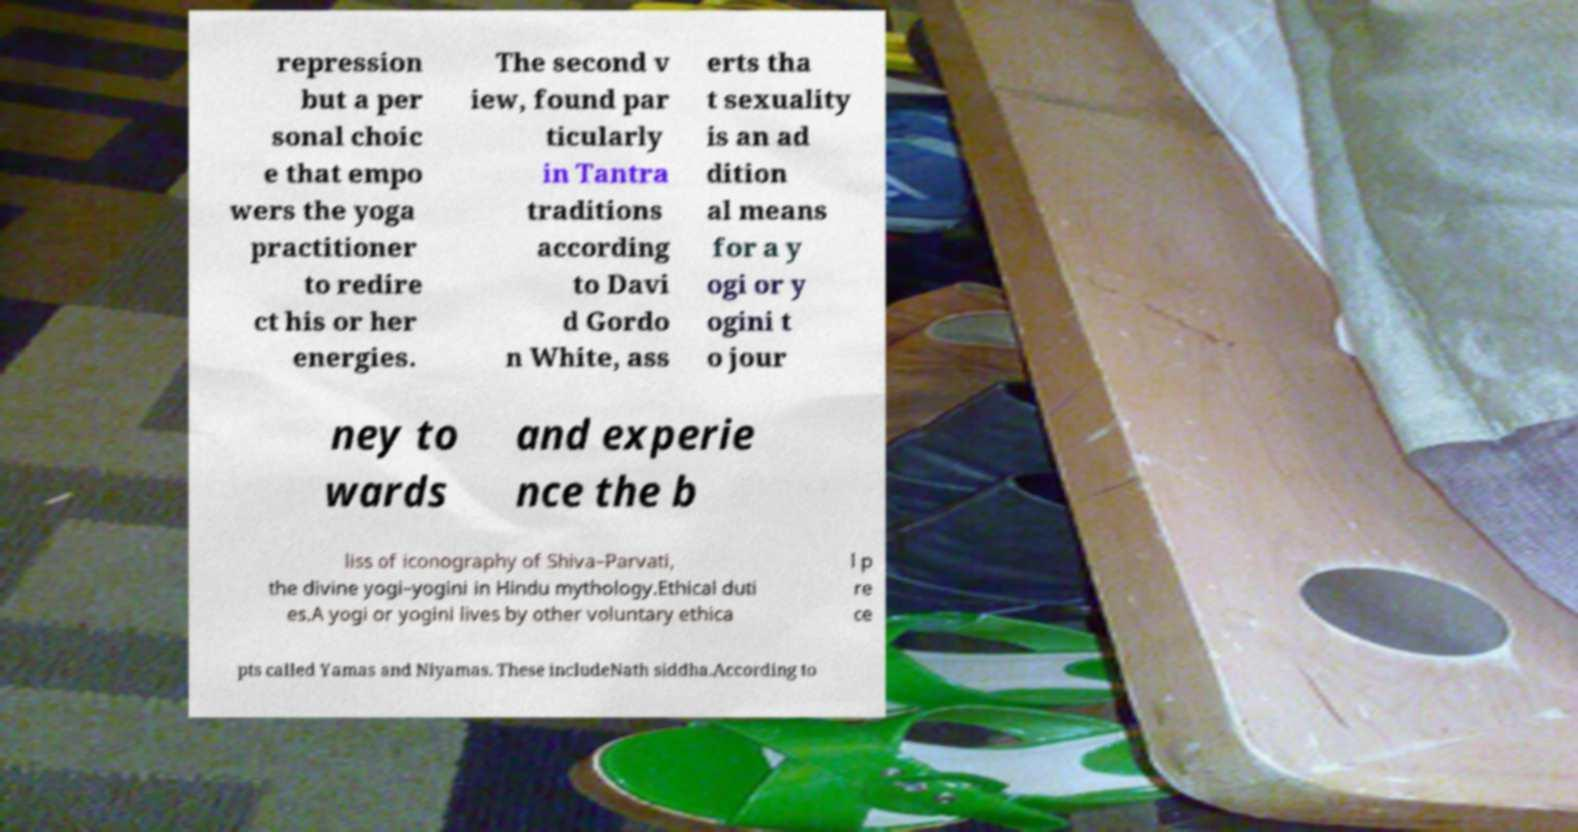For documentation purposes, I need the text within this image transcribed. Could you provide that? repression but a per sonal choic e that empo wers the yoga practitioner to redire ct his or her energies. The second v iew, found par ticularly in Tantra traditions according to Davi d Gordo n White, ass erts tha t sexuality is an ad dition al means for a y ogi or y ogini t o jour ney to wards and experie nce the b liss of iconography of Shiva–Parvati, the divine yogi–yogini in Hindu mythology.Ethical duti es.A yogi or yogini lives by other voluntary ethica l p re ce pts called Yamas and Niyamas. These includeNath siddha.According to 